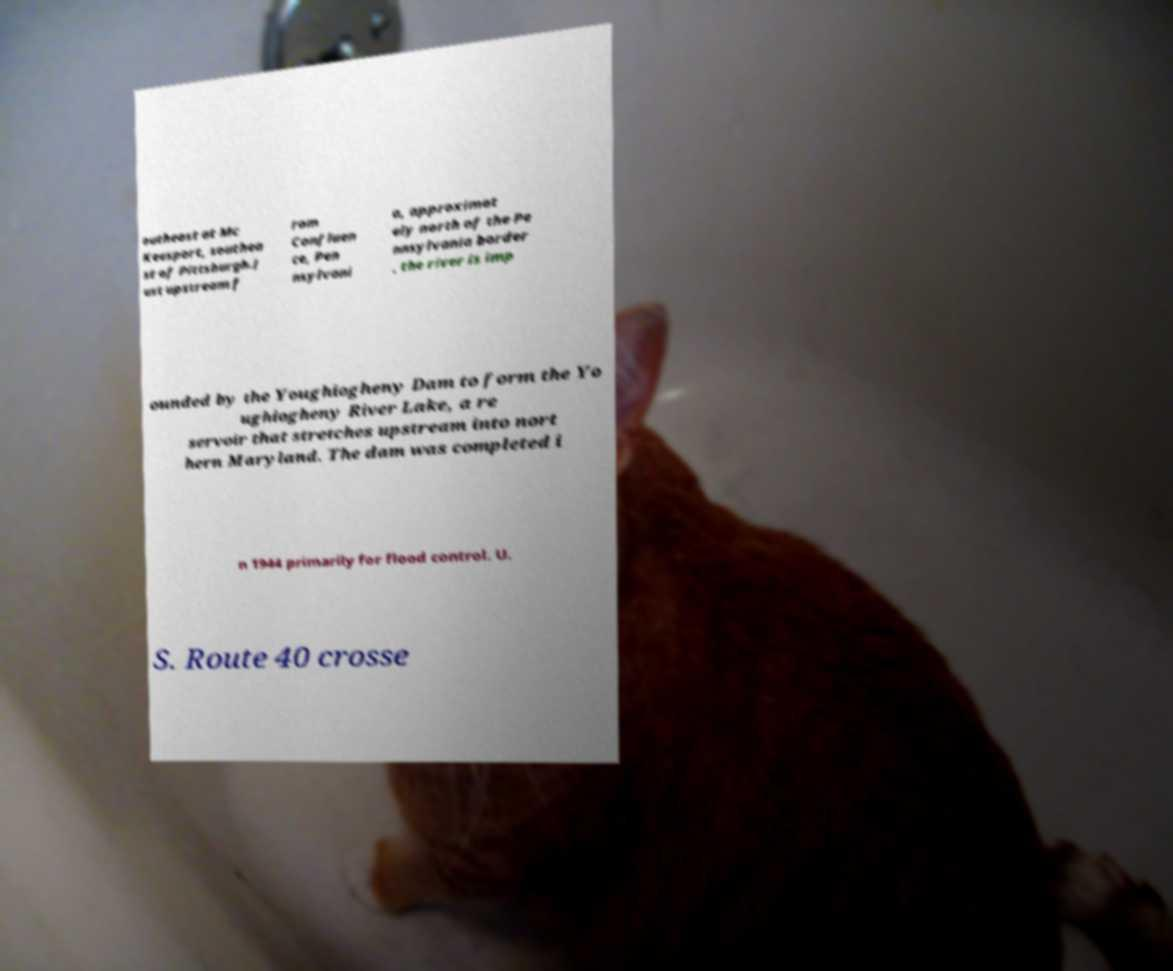Please read and relay the text visible in this image. What does it say? outheast at Mc Keesport, southea st of Pittsburgh.J ust upstream f rom Confluen ce, Pen nsylvani a, approximat ely north of the Pe nnsylvania border , the river is imp ounded by the Youghiogheny Dam to form the Yo ughiogheny River Lake, a re servoir that stretches upstream into nort hern Maryland. The dam was completed i n 1944 primarily for flood control. U. S. Route 40 crosse 